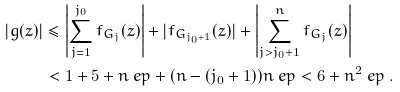Convert formula to latex. <formula><loc_0><loc_0><loc_500><loc_500>| g ( z ) | & \leq \left | \sum _ { j = 1 } ^ { j _ { 0 } } f _ { G _ { j } } ( z ) \right | + | f _ { G _ { j _ { 0 } + 1 } } ( z ) | + \left | \sum _ { j > j _ { 0 } + 1 } ^ { n } f _ { G _ { j } } ( z ) \right | \\ & < 1 + 5 + n \ e p + ( n - ( j _ { 0 } + 1 ) ) n \ e p < 6 + n ^ { 2 } \ e p \ .</formula> 